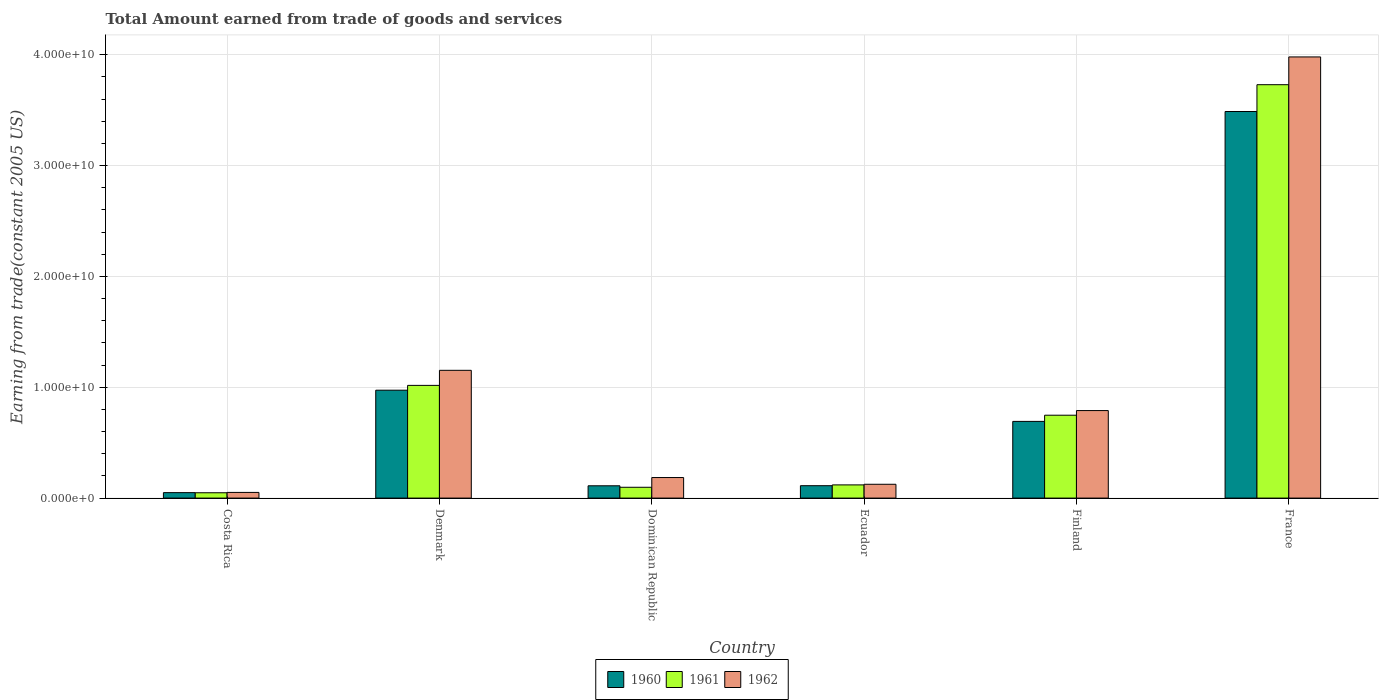How many different coloured bars are there?
Provide a short and direct response. 3. Are the number of bars per tick equal to the number of legend labels?
Provide a short and direct response. Yes. How many bars are there on the 3rd tick from the right?
Ensure brevity in your answer.  3. What is the total amount earned by trading goods and services in 1960 in Denmark?
Offer a very short reply. 9.74e+09. Across all countries, what is the maximum total amount earned by trading goods and services in 1961?
Keep it short and to the point. 3.73e+1. Across all countries, what is the minimum total amount earned by trading goods and services in 1962?
Keep it short and to the point. 5.12e+08. In which country was the total amount earned by trading goods and services in 1960 minimum?
Your answer should be compact. Costa Rica. What is the total total amount earned by trading goods and services in 1962 in the graph?
Make the answer very short. 6.28e+1. What is the difference between the total amount earned by trading goods and services in 1962 in Costa Rica and that in Finland?
Give a very brief answer. -7.39e+09. What is the difference between the total amount earned by trading goods and services in 1960 in Dominican Republic and the total amount earned by trading goods and services in 1962 in Denmark?
Provide a short and direct response. -1.04e+1. What is the average total amount earned by trading goods and services in 1962 per country?
Provide a short and direct response. 1.05e+1. What is the difference between the total amount earned by trading goods and services of/in 1960 and total amount earned by trading goods and services of/in 1962 in Dominican Republic?
Make the answer very short. -7.45e+08. In how many countries, is the total amount earned by trading goods and services in 1960 greater than 2000000000 US$?
Offer a very short reply. 3. What is the ratio of the total amount earned by trading goods and services in 1962 in Costa Rica to that in Ecuador?
Provide a short and direct response. 0.41. Is the total amount earned by trading goods and services in 1960 in Denmark less than that in Ecuador?
Your answer should be very brief. No. What is the difference between the highest and the second highest total amount earned by trading goods and services in 1962?
Keep it short and to the point. -2.83e+1. What is the difference between the highest and the lowest total amount earned by trading goods and services in 1960?
Your response must be concise. 3.44e+1. What does the 3rd bar from the left in Dominican Republic represents?
Provide a succinct answer. 1962. Is it the case that in every country, the sum of the total amount earned by trading goods and services in 1960 and total amount earned by trading goods and services in 1962 is greater than the total amount earned by trading goods and services in 1961?
Your answer should be compact. Yes. How many bars are there?
Offer a very short reply. 18. Are all the bars in the graph horizontal?
Your answer should be compact. No. Are the values on the major ticks of Y-axis written in scientific E-notation?
Your answer should be compact. Yes. Does the graph contain any zero values?
Your answer should be compact. No. Does the graph contain grids?
Make the answer very short. Yes. What is the title of the graph?
Your answer should be compact. Total Amount earned from trade of goods and services. What is the label or title of the Y-axis?
Your response must be concise. Earning from trade(constant 2005 US). What is the Earning from trade(constant 2005 US) of 1960 in Costa Rica?
Keep it short and to the point. 4.92e+08. What is the Earning from trade(constant 2005 US) of 1961 in Costa Rica?
Provide a short and direct response. 4.81e+08. What is the Earning from trade(constant 2005 US) in 1962 in Costa Rica?
Offer a very short reply. 5.12e+08. What is the Earning from trade(constant 2005 US) of 1960 in Denmark?
Make the answer very short. 9.74e+09. What is the Earning from trade(constant 2005 US) in 1961 in Denmark?
Your answer should be compact. 1.02e+1. What is the Earning from trade(constant 2005 US) of 1962 in Denmark?
Ensure brevity in your answer.  1.15e+1. What is the Earning from trade(constant 2005 US) in 1960 in Dominican Republic?
Provide a succinct answer. 1.11e+09. What is the Earning from trade(constant 2005 US) in 1961 in Dominican Republic?
Make the answer very short. 9.76e+08. What is the Earning from trade(constant 2005 US) in 1962 in Dominican Republic?
Offer a very short reply. 1.86e+09. What is the Earning from trade(constant 2005 US) of 1960 in Ecuador?
Your answer should be compact. 1.12e+09. What is the Earning from trade(constant 2005 US) in 1961 in Ecuador?
Offer a terse response. 1.19e+09. What is the Earning from trade(constant 2005 US) of 1962 in Ecuador?
Your answer should be very brief. 1.25e+09. What is the Earning from trade(constant 2005 US) in 1960 in Finland?
Your answer should be compact. 6.92e+09. What is the Earning from trade(constant 2005 US) of 1961 in Finland?
Make the answer very short. 7.48e+09. What is the Earning from trade(constant 2005 US) of 1962 in Finland?
Your answer should be compact. 7.90e+09. What is the Earning from trade(constant 2005 US) in 1960 in France?
Make the answer very short. 3.49e+1. What is the Earning from trade(constant 2005 US) of 1961 in France?
Offer a terse response. 3.73e+1. What is the Earning from trade(constant 2005 US) in 1962 in France?
Keep it short and to the point. 3.98e+1. Across all countries, what is the maximum Earning from trade(constant 2005 US) in 1960?
Make the answer very short. 3.49e+1. Across all countries, what is the maximum Earning from trade(constant 2005 US) of 1961?
Provide a succinct answer. 3.73e+1. Across all countries, what is the maximum Earning from trade(constant 2005 US) in 1962?
Your answer should be very brief. 3.98e+1. Across all countries, what is the minimum Earning from trade(constant 2005 US) of 1960?
Make the answer very short. 4.92e+08. Across all countries, what is the minimum Earning from trade(constant 2005 US) of 1961?
Give a very brief answer. 4.81e+08. Across all countries, what is the minimum Earning from trade(constant 2005 US) in 1962?
Make the answer very short. 5.12e+08. What is the total Earning from trade(constant 2005 US) of 1960 in the graph?
Make the answer very short. 5.43e+1. What is the total Earning from trade(constant 2005 US) of 1961 in the graph?
Your answer should be compact. 5.76e+1. What is the total Earning from trade(constant 2005 US) of 1962 in the graph?
Your answer should be compact. 6.28e+1. What is the difference between the Earning from trade(constant 2005 US) of 1960 in Costa Rica and that in Denmark?
Your response must be concise. -9.24e+09. What is the difference between the Earning from trade(constant 2005 US) of 1961 in Costa Rica and that in Denmark?
Your answer should be compact. -9.69e+09. What is the difference between the Earning from trade(constant 2005 US) of 1962 in Costa Rica and that in Denmark?
Give a very brief answer. -1.10e+1. What is the difference between the Earning from trade(constant 2005 US) in 1960 in Costa Rica and that in Dominican Republic?
Give a very brief answer. -6.17e+08. What is the difference between the Earning from trade(constant 2005 US) of 1961 in Costa Rica and that in Dominican Republic?
Make the answer very short. -4.95e+08. What is the difference between the Earning from trade(constant 2005 US) in 1962 in Costa Rica and that in Dominican Republic?
Your answer should be very brief. -1.34e+09. What is the difference between the Earning from trade(constant 2005 US) in 1960 in Costa Rica and that in Ecuador?
Offer a very short reply. -6.26e+08. What is the difference between the Earning from trade(constant 2005 US) in 1961 in Costa Rica and that in Ecuador?
Your response must be concise. -7.09e+08. What is the difference between the Earning from trade(constant 2005 US) in 1962 in Costa Rica and that in Ecuador?
Make the answer very short. -7.35e+08. What is the difference between the Earning from trade(constant 2005 US) of 1960 in Costa Rica and that in Finland?
Provide a succinct answer. -6.43e+09. What is the difference between the Earning from trade(constant 2005 US) of 1961 in Costa Rica and that in Finland?
Make the answer very short. -7.00e+09. What is the difference between the Earning from trade(constant 2005 US) of 1962 in Costa Rica and that in Finland?
Your answer should be very brief. -7.39e+09. What is the difference between the Earning from trade(constant 2005 US) in 1960 in Costa Rica and that in France?
Your answer should be compact. -3.44e+1. What is the difference between the Earning from trade(constant 2005 US) of 1961 in Costa Rica and that in France?
Give a very brief answer. -3.68e+1. What is the difference between the Earning from trade(constant 2005 US) of 1962 in Costa Rica and that in France?
Your answer should be very brief. -3.93e+1. What is the difference between the Earning from trade(constant 2005 US) in 1960 in Denmark and that in Dominican Republic?
Keep it short and to the point. 8.63e+09. What is the difference between the Earning from trade(constant 2005 US) of 1961 in Denmark and that in Dominican Republic?
Provide a short and direct response. 9.19e+09. What is the difference between the Earning from trade(constant 2005 US) of 1962 in Denmark and that in Dominican Republic?
Your response must be concise. 9.67e+09. What is the difference between the Earning from trade(constant 2005 US) of 1960 in Denmark and that in Ecuador?
Ensure brevity in your answer.  8.62e+09. What is the difference between the Earning from trade(constant 2005 US) in 1961 in Denmark and that in Ecuador?
Offer a very short reply. 8.98e+09. What is the difference between the Earning from trade(constant 2005 US) in 1962 in Denmark and that in Ecuador?
Offer a very short reply. 1.03e+1. What is the difference between the Earning from trade(constant 2005 US) in 1960 in Denmark and that in Finland?
Your answer should be very brief. 2.82e+09. What is the difference between the Earning from trade(constant 2005 US) of 1961 in Denmark and that in Finland?
Offer a very short reply. 2.69e+09. What is the difference between the Earning from trade(constant 2005 US) of 1962 in Denmark and that in Finland?
Your answer should be compact. 3.63e+09. What is the difference between the Earning from trade(constant 2005 US) of 1960 in Denmark and that in France?
Keep it short and to the point. -2.51e+1. What is the difference between the Earning from trade(constant 2005 US) of 1961 in Denmark and that in France?
Give a very brief answer. -2.71e+1. What is the difference between the Earning from trade(constant 2005 US) of 1962 in Denmark and that in France?
Give a very brief answer. -2.83e+1. What is the difference between the Earning from trade(constant 2005 US) in 1960 in Dominican Republic and that in Ecuador?
Your answer should be very brief. -8.29e+06. What is the difference between the Earning from trade(constant 2005 US) of 1961 in Dominican Republic and that in Ecuador?
Keep it short and to the point. -2.14e+08. What is the difference between the Earning from trade(constant 2005 US) of 1962 in Dominican Republic and that in Ecuador?
Your response must be concise. 6.08e+08. What is the difference between the Earning from trade(constant 2005 US) in 1960 in Dominican Republic and that in Finland?
Offer a terse response. -5.81e+09. What is the difference between the Earning from trade(constant 2005 US) of 1961 in Dominican Republic and that in Finland?
Your answer should be very brief. -6.50e+09. What is the difference between the Earning from trade(constant 2005 US) of 1962 in Dominican Republic and that in Finland?
Your answer should be very brief. -6.04e+09. What is the difference between the Earning from trade(constant 2005 US) in 1960 in Dominican Republic and that in France?
Provide a succinct answer. -3.38e+1. What is the difference between the Earning from trade(constant 2005 US) of 1961 in Dominican Republic and that in France?
Ensure brevity in your answer.  -3.63e+1. What is the difference between the Earning from trade(constant 2005 US) of 1962 in Dominican Republic and that in France?
Offer a terse response. -3.80e+1. What is the difference between the Earning from trade(constant 2005 US) of 1960 in Ecuador and that in Finland?
Provide a short and direct response. -5.80e+09. What is the difference between the Earning from trade(constant 2005 US) in 1961 in Ecuador and that in Finland?
Ensure brevity in your answer.  -6.29e+09. What is the difference between the Earning from trade(constant 2005 US) in 1962 in Ecuador and that in Finland?
Your answer should be very brief. -6.65e+09. What is the difference between the Earning from trade(constant 2005 US) of 1960 in Ecuador and that in France?
Offer a very short reply. -3.38e+1. What is the difference between the Earning from trade(constant 2005 US) in 1961 in Ecuador and that in France?
Keep it short and to the point. -3.61e+1. What is the difference between the Earning from trade(constant 2005 US) in 1962 in Ecuador and that in France?
Your response must be concise. -3.86e+1. What is the difference between the Earning from trade(constant 2005 US) of 1960 in Finland and that in France?
Your answer should be very brief. -2.80e+1. What is the difference between the Earning from trade(constant 2005 US) of 1961 in Finland and that in France?
Offer a terse response. -2.98e+1. What is the difference between the Earning from trade(constant 2005 US) of 1962 in Finland and that in France?
Give a very brief answer. -3.19e+1. What is the difference between the Earning from trade(constant 2005 US) of 1960 in Costa Rica and the Earning from trade(constant 2005 US) of 1961 in Denmark?
Make the answer very short. -9.68e+09. What is the difference between the Earning from trade(constant 2005 US) in 1960 in Costa Rica and the Earning from trade(constant 2005 US) in 1962 in Denmark?
Your answer should be compact. -1.10e+1. What is the difference between the Earning from trade(constant 2005 US) of 1961 in Costa Rica and the Earning from trade(constant 2005 US) of 1962 in Denmark?
Your answer should be very brief. -1.10e+1. What is the difference between the Earning from trade(constant 2005 US) of 1960 in Costa Rica and the Earning from trade(constant 2005 US) of 1961 in Dominican Republic?
Provide a succinct answer. -4.84e+08. What is the difference between the Earning from trade(constant 2005 US) in 1960 in Costa Rica and the Earning from trade(constant 2005 US) in 1962 in Dominican Republic?
Your answer should be very brief. -1.36e+09. What is the difference between the Earning from trade(constant 2005 US) in 1961 in Costa Rica and the Earning from trade(constant 2005 US) in 1962 in Dominican Republic?
Ensure brevity in your answer.  -1.37e+09. What is the difference between the Earning from trade(constant 2005 US) in 1960 in Costa Rica and the Earning from trade(constant 2005 US) in 1961 in Ecuador?
Ensure brevity in your answer.  -6.98e+08. What is the difference between the Earning from trade(constant 2005 US) of 1960 in Costa Rica and the Earning from trade(constant 2005 US) of 1962 in Ecuador?
Provide a succinct answer. -7.55e+08. What is the difference between the Earning from trade(constant 2005 US) in 1961 in Costa Rica and the Earning from trade(constant 2005 US) in 1962 in Ecuador?
Your answer should be very brief. -7.66e+08. What is the difference between the Earning from trade(constant 2005 US) in 1960 in Costa Rica and the Earning from trade(constant 2005 US) in 1961 in Finland?
Offer a terse response. -6.99e+09. What is the difference between the Earning from trade(constant 2005 US) of 1960 in Costa Rica and the Earning from trade(constant 2005 US) of 1962 in Finland?
Provide a short and direct response. -7.41e+09. What is the difference between the Earning from trade(constant 2005 US) of 1961 in Costa Rica and the Earning from trade(constant 2005 US) of 1962 in Finland?
Your answer should be compact. -7.42e+09. What is the difference between the Earning from trade(constant 2005 US) of 1960 in Costa Rica and the Earning from trade(constant 2005 US) of 1961 in France?
Your answer should be very brief. -3.68e+1. What is the difference between the Earning from trade(constant 2005 US) in 1960 in Costa Rica and the Earning from trade(constant 2005 US) in 1962 in France?
Keep it short and to the point. -3.93e+1. What is the difference between the Earning from trade(constant 2005 US) in 1961 in Costa Rica and the Earning from trade(constant 2005 US) in 1962 in France?
Offer a very short reply. -3.93e+1. What is the difference between the Earning from trade(constant 2005 US) in 1960 in Denmark and the Earning from trade(constant 2005 US) in 1961 in Dominican Republic?
Make the answer very short. 8.76e+09. What is the difference between the Earning from trade(constant 2005 US) in 1960 in Denmark and the Earning from trade(constant 2005 US) in 1962 in Dominican Republic?
Offer a terse response. 7.88e+09. What is the difference between the Earning from trade(constant 2005 US) in 1961 in Denmark and the Earning from trade(constant 2005 US) in 1962 in Dominican Republic?
Offer a very short reply. 8.31e+09. What is the difference between the Earning from trade(constant 2005 US) of 1960 in Denmark and the Earning from trade(constant 2005 US) of 1961 in Ecuador?
Offer a very short reply. 8.55e+09. What is the difference between the Earning from trade(constant 2005 US) of 1960 in Denmark and the Earning from trade(constant 2005 US) of 1962 in Ecuador?
Provide a short and direct response. 8.49e+09. What is the difference between the Earning from trade(constant 2005 US) in 1961 in Denmark and the Earning from trade(constant 2005 US) in 1962 in Ecuador?
Give a very brief answer. 8.92e+09. What is the difference between the Earning from trade(constant 2005 US) of 1960 in Denmark and the Earning from trade(constant 2005 US) of 1961 in Finland?
Offer a terse response. 2.26e+09. What is the difference between the Earning from trade(constant 2005 US) of 1960 in Denmark and the Earning from trade(constant 2005 US) of 1962 in Finland?
Make the answer very short. 1.84e+09. What is the difference between the Earning from trade(constant 2005 US) of 1961 in Denmark and the Earning from trade(constant 2005 US) of 1962 in Finland?
Provide a succinct answer. 2.27e+09. What is the difference between the Earning from trade(constant 2005 US) of 1960 in Denmark and the Earning from trade(constant 2005 US) of 1961 in France?
Provide a short and direct response. -2.76e+1. What is the difference between the Earning from trade(constant 2005 US) in 1960 in Denmark and the Earning from trade(constant 2005 US) in 1962 in France?
Make the answer very short. -3.01e+1. What is the difference between the Earning from trade(constant 2005 US) in 1961 in Denmark and the Earning from trade(constant 2005 US) in 1962 in France?
Keep it short and to the point. -2.96e+1. What is the difference between the Earning from trade(constant 2005 US) in 1960 in Dominican Republic and the Earning from trade(constant 2005 US) in 1961 in Ecuador?
Your answer should be compact. -8.07e+07. What is the difference between the Earning from trade(constant 2005 US) of 1960 in Dominican Republic and the Earning from trade(constant 2005 US) of 1962 in Ecuador?
Your response must be concise. -1.37e+08. What is the difference between the Earning from trade(constant 2005 US) of 1961 in Dominican Republic and the Earning from trade(constant 2005 US) of 1962 in Ecuador?
Your answer should be very brief. -2.71e+08. What is the difference between the Earning from trade(constant 2005 US) in 1960 in Dominican Republic and the Earning from trade(constant 2005 US) in 1961 in Finland?
Your response must be concise. -6.37e+09. What is the difference between the Earning from trade(constant 2005 US) of 1960 in Dominican Republic and the Earning from trade(constant 2005 US) of 1962 in Finland?
Your answer should be very brief. -6.79e+09. What is the difference between the Earning from trade(constant 2005 US) in 1961 in Dominican Republic and the Earning from trade(constant 2005 US) in 1962 in Finland?
Your answer should be very brief. -6.92e+09. What is the difference between the Earning from trade(constant 2005 US) in 1960 in Dominican Republic and the Earning from trade(constant 2005 US) in 1961 in France?
Your answer should be compact. -3.62e+1. What is the difference between the Earning from trade(constant 2005 US) of 1960 in Dominican Republic and the Earning from trade(constant 2005 US) of 1962 in France?
Ensure brevity in your answer.  -3.87e+1. What is the difference between the Earning from trade(constant 2005 US) in 1961 in Dominican Republic and the Earning from trade(constant 2005 US) in 1962 in France?
Offer a terse response. -3.88e+1. What is the difference between the Earning from trade(constant 2005 US) in 1960 in Ecuador and the Earning from trade(constant 2005 US) in 1961 in Finland?
Give a very brief answer. -6.36e+09. What is the difference between the Earning from trade(constant 2005 US) of 1960 in Ecuador and the Earning from trade(constant 2005 US) of 1962 in Finland?
Keep it short and to the point. -6.78e+09. What is the difference between the Earning from trade(constant 2005 US) of 1961 in Ecuador and the Earning from trade(constant 2005 US) of 1962 in Finland?
Ensure brevity in your answer.  -6.71e+09. What is the difference between the Earning from trade(constant 2005 US) of 1960 in Ecuador and the Earning from trade(constant 2005 US) of 1961 in France?
Keep it short and to the point. -3.62e+1. What is the difference between the Earning from trade(constant 2005 US) in 1960 in Ecuador and the Earning from trade(constant 2005 US) in 1962 in France?
Give a very brief answer. -3.87e+1. What is the difference between the Earning from trade(constant 2005 US) of 1961 in Ecuador and the Earning from trade(constant 2005 US) of 1962 in France?
Your response must be concise. -3.86e+1. What is the difference between the Earning from trade(constant 2005 US) in 1960 in Finland and the Earning from trade(constant 2005 US) in 1961 in France?
Offer a very short reply. -3.04e+1. What is the difference between the Earning from trade(constant 2005 US) of 1960 in Finland and the Earning from trade(constant 2005 US) of 1962 in France?
Provide a short and direct response. -3.29e+1. What is the difference between the Earning from trade(constant 2005 US) in 1961 in Finland and the Earning from trade(constant 2005 US) in 1962 in France?
Give a very brief answer. -3.23e+1. What is the average Earning from trade(constant 2005 US) in 1960 per country?
Provide a succinct answer. 9.04e+09. What is the average Earning from trade(constant 2005 US) of 1961 per country?
Offer a very short reply. 9.60e+09. What is the average Earning from trade(constant 2005 US) in 1962 per country?
Offer a very short reply. 1.05e+1. What is the difference between the Earning from trade(constant 2005 US) of 1960 and Earning from trade(constant 2005 US) of 1961 in Costa Rica?
Offer a very short reply. 1.09e+07. What is the difference between the Earning from trade(constant 2005 US) of 1960 and Earning from trade(constant 2005 US) of 1962 in Costa Rica?
Your response must be concise. -1.99e+07. What is the difference between the Earning from trade(constant 2005 US) of 1961 and Earning from trade(constant 2005 US) of 1962 in Costa Rica?
Provide a succinct answer. -3.08e+07. What is the difference between the Earning from trade(constant 2005 US) in 1960 and Earning from trade(constant 2005 US) in 1961 in Denmark?
Provide a short and direct response. -4.33e+08. What is the difference between the Earning from trade(constant 2005 US) in 1960 and Earning from trade(constant 2005 US) in 1962 in Denmark?
Offer a very short reply. -1.79e+09. What is the difference between the Earning from trade(constant 2005 US) of 1961 and Earning from trade(constant 2005 US) of 1962 in Denmark?
Ensure brevity in your answer.  -1.36e+09. What is the difference between the Earning from trade(constant 2005 US) of 1960 and Earning from trade(constant 2005 US) of 1961 in Dominican Republic?
Your response must be concise. 1.34e+08. What is the difference between the Earning from trade(constant 2005 US) in 1960 and Earning from trade(constant 2005 US) in 1962 in Dominican Republic?
Keep it short and to the point. -7.45e+08. What is the difference between the Earning from trade(constant 2005 US) in 1961 and Earning from trade(constant 2005 US) in 1962 in Dominican Republic?
Offer a very short reply. -8.79e+08. What is the difference between the Earning from trade(constant 2005 US) in 1960 and Earning from trade(constant 2005 US) in 1961 in Ecuador?
Offer a very short reply. -7.24e+07. What is the difference between the Earning from trade(constant 2005 US) of 1960 and Earning from trade(constant 2005 US) of 1962 in Ecuador?
Provide a succinct answer. -1.29e+08. What is the difference between the Earning from trade(constant 2005 US) of 1961 and Earning from trade(constant 2005 US) of 1962 in Ecuador?
Give a very brief answer. -5.67e+07. What is the difference between the Earning from trade(constant 2005 US) in 1960 and Earning from trade(constant 2005 US) in 1961 in Finland?
Provide a succinct answer. -5.58e+08. What is the difference between the Earning from trade(constant 2005 US) of 1960 and Earning from trade(constant 2005 US) of 1962 in Finland?
Give a very brief answer. -9.78e+08. What is the difference between the Earning from trade(constant 2005 US) of 1961 and Earning from trade(constant 2005 US) of 1962 in Finland?
Ensure brevity in your answer.  -4.20e+08. What is the difference between the Earning from trade(constant 2005 US) of 1960 and Earning from trade(constant 2005 US) of 1961 in France?
Make the answer very short. -2.42e+09. What is the difference between the Earning from trade(constant 2005 US) of 1960 and Earning from trade(constant 2005 US) of 1962 in France?
Make the answer very short. -4.92e+09. What is the difference between the Earning from trade(constant 2005 US) in 1961 and Earning from trade(constant 2005 US) in 1962 in France?
Ensure brevity in your answer.  -2.50e+09. What is the ratio of the Earning from trade(constant 2005 US) of 1960 in Costa Rica to that in Denmark?
Ensure brevity in your answer.  0.05. What is the ratio of the Earning from trade(constant 2005 US) of 1961 in Costa Rica to that in Denmark?
Keep it short and to the point. 0.05. What is the ratio of the Earning from trade(constant 2005 US) in 1962 in Costa Rica to that in Denmark?
Provide a short and direct response. 0.04. What is the ratio of the Earning from trade(constant 2005 US) of 1960 in Costa Rica to that in Dominican Republic?
Your response must be concise. 0.44. What is the ratio of the Earning from trade(constant 2005 US) of 1961 in Costa Rica to that in Dominican Republic?
Your answer should be compact. 0.49. What is the ratio of the Earning from trade(constant 2005 US) of 1962 in Costa Rica to that in Dominican Republic?
Your answer should be very brief. 0.28. What is the ratio of the Earning from trade(constant 2005 US) in 1960 in Costa Rica to that in Ecuador?
Your answer should be very brief. 0.44. What is the ratio of the Earning from trade(constant 2005 US) of 1961 in Costa Rica to that in Ecuador?
Provide a short and direct response. 0.4. What is the ratio of the Earning from trade(constant 2005 US) of 1962 in Costa Rica to that in Ecuador?
Offer a very short reply. 0.41. What is the ratio of the Earning from trade(constant 2005 US) in 1960 in Costa Rica to that in Finland?
Ensure brevity in your answer.  0.07. What is the ratio of the Earning from trade(constant 2005 US) in 1961 in Costa Rica to that in Finland?
Give a very brief answer. 0.06. What is the ratio of the Earning from trade(constant 2005 US) of 1962 in Costa Rica to that in Finland?
Make the answer very short. 0.06. What is the ratio of the Earning from trade(constant 2005 US) of 1960 in Costa Rica to that in France?
Provide a succinct answer. 0.01. What is the ratio of the Earning from trade(constant 2005 US) of 1961 in Costa Rica to that in France?
Provide a succinct answer. 0.01. What is the ratio of the Earning from trade(constant 2005 US) in 1962 in Costa Rica to that in France?
Your response must be concise. 0.01. What is the ratio of the Earning from trade(constant 2005 US) in 1960 in Denmark to that in Dominican Republic?
Provide a succinct answer. 8.77. What is the ratio of the Earning from trade(constant 2005 US) in 1961 in Denmark to that in Dominican Republic?
Keep it short and to the point. 10.42. What is the ratio of the Earning from trade(constant 2005 US) in 1962 in Denmark to that in Dominican Republic?
Keep it short and to the point. 6.21. What is the ratio of the Earning from trade(constant 2005 US) of 1960 in Denmark to that in Ecuador?
Make the answer very short. 8.71. What is the ratio of the Earning from trade(constant 2005 US) in 1961 in Denmark to that in Ecuador?
Your response must be concise. 8.54. What is the ratio of the Earning from trade(constant 2005 US) in 1962 in Denmark to that in Ecuador?
Offer a terse response. 9.24. What is the ratio of the Earning from trade(constant 2005 US) in 1960 in Denmark to that in Finland?
Make the answer very short. 1.41. What is the ratio of the Earning from trade(constant 2005 US) of 1961 in Denmark to that in Finland?
Keep it short and to the point. 1.36. What is the ratio of the Earning from trade(constant 2005 US) of 1962 in Denmark to that in Finland?
Provide a succinct answer. 1.46. What is the ratio of the Earning from trade(constant 2005 US) in 1960 in Denmark to that in France?
Ensure brevity in your answer.  0.28. What is the ratio of the Earning from trade(constant 2005 US) of 1961 in Denmark to that in France?
Ensure brevity in your answer.  0.27. What is the ratio of the Earning from trade(constant 2005 US) in 1962 in Denmark to that in France?
Give a very brief answer. 0.29. What is the ratio of the Earning from trade(constant 2005 US) of 1960 in Dominican Republic to that in Ecuador?
Provide a short and direct response. 0.99. What is the ratio of the Earning from trade(constant 2005 US) in 1961 in Dominican Republic to that in Ecuador?
Your answer should be very brief. 0.82. What is the ratio of the Earning from trade(constant 2005 US) in 1962 in Dominican Republic to that in Ecuador?
Offer a very short reply. 1.49. What is the ratio of the Earning from trade(constant 2005 US) in 1960 in Dominican Republic to that in Finland?
Your answer should be compact. 0.16. What is the ratio of the Earning from trade(constant 2005 US) in 1961 in Dominican Republic to that in Finland?
Keep it short and to the point. 0.13. What is the ratio of the Earning from trade(constant 2005 US) in 1962 in Dominican Republic to that in Finland?
Your answer should be compact. 0.23. What is the ratio of the Earning from trade(constant 2005 US) in 1960 in Dominican Republic to that in France?
Offer a terse response. 0.03. What is the ratio of the Earning from trade(constant 2005 US) of 1961 in Dominican Republic to that in France?
Your answer should be compact. 0.03. What is the ratio of the Earning from trade(constant 2005 US) of 1962 in Dominican Republic to that in France?
Give a very brief answer. 0.05. What is the ratio of the Earning from trade(constant 2005 US) of 1960 in Ecuador to that in Finland?
Your answer should be very brief. 0.16. What is the ratio of the Earning from trade(constant 2005 US) in 1961 in Ecuador to that in Finland?
Provide a succinct answer. 0.16. What is the ratio of the Earning from trade(constant 2005 US) in 1962 in Ecuador to that in Finland?
Offer a terse response. 0.16. What is the ratio of the Earning from trade(constant 2005 US) in 1960 in Ecuador to that in France?
Give a very brief answer. 0.03. What is the ratio of the Earning from trade(constant 2005 US) in 1961 in Ecuador to that in France?
Your answer should be very brief. 0.03. What is the ratio of the Earning from trade(constant 2005 US) of 1962 in Ecuador to that in France?
Ensure brevity in your answer.  0.03. What is the ratio of the Earning from trade(constant 2005 US) of 1960 in Finland to that in France?
Offer a very short reply. 0.2. What is the ratio of the Earning from trade(constant 2005 US) in 1961 in Finland to that in France?
Offer a very short reply. 0.2. What is the ratio of the Earning from trade(constant 2005 US) in 1962 in Finland to that in France?
Ensure brevity in your answer.  0.2. What is the difference between the highest and the second highest Earning from trade(constant 2005 US) of 1960?
Provide a succinct answer. 2.51e+1. What is the difference between the highest and the second highest Earning from trade(constant 2005 US) in 1961?
Provide a short and direct response. 2.71e+1. What is the difference between the highest and the second highest Earning from trade(constant 2005 US) in 1962?
Your answer should be very brief. 2.83e+1. What is the difference between the highest and the lowest Earning from trade(constant 2005 US) in 1960?
Your response must be concise. 3.44e+1. What is the difference between the highest and the lowest Earning from trade(constant 2005 US) in 1961?
Ensure brevity in your answer.  3.68e+1. What is the difference between the highest and the lowest Earning from trade(constant 2005 US) of 1962?
Provide a short and direct response. 3.93e+1. 